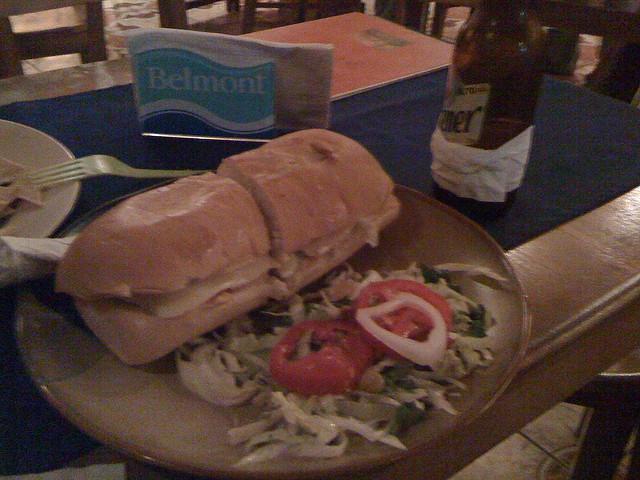How many chairs can you see?
Give a very brief answer. 3. How many dining tables are there?
Give a very brief answer. 2. How many people are probably going to eat this food?
Give a very brief answer. 0. 